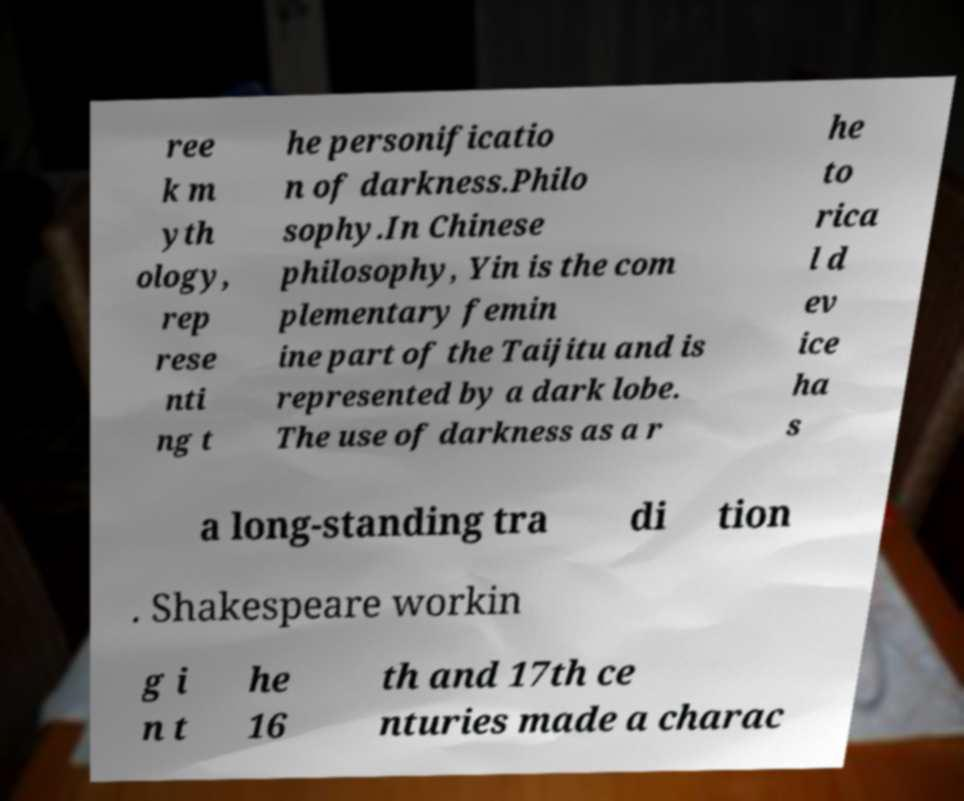Please identify and transcribe the text found in this image. ree k m yth ology, rep rese nti ng t he personificatio n of darkness.Philo sophy.In Chinese philosophy, Yin is the com plementary femin ine part of the Taijitu and is represented by a dark lobe. The use of darkness as a r he to rica l d ev ice ha s a long-standing tra di tion . Shakespeare workin g i n t he 16 th and 17th ce nturies made a charac 